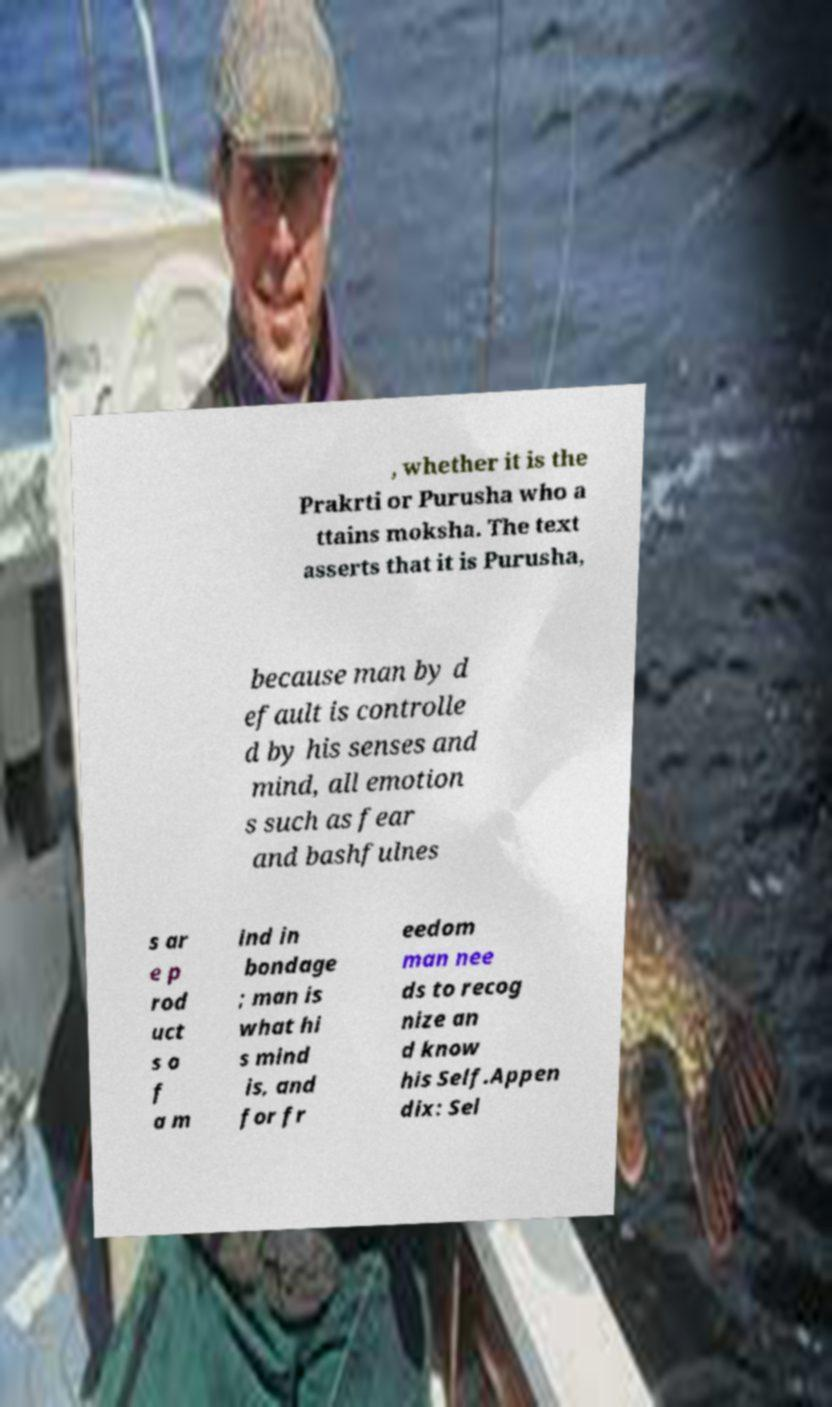Please read and relay the text visible in this image. What does it say? , whether it is the Prakrti or Purusha who a ttains moksha. The text asserts that it is Purusha, because man by d efault is controlle d by his senses and mind, all emotion s such as fear and bashfulnes s ar e p rod uct s o f a m ind in bondage ; man is what hi s mind is, and for fr eedom man nee ds to recog nize an d know his Self.Appen dix: Sel 